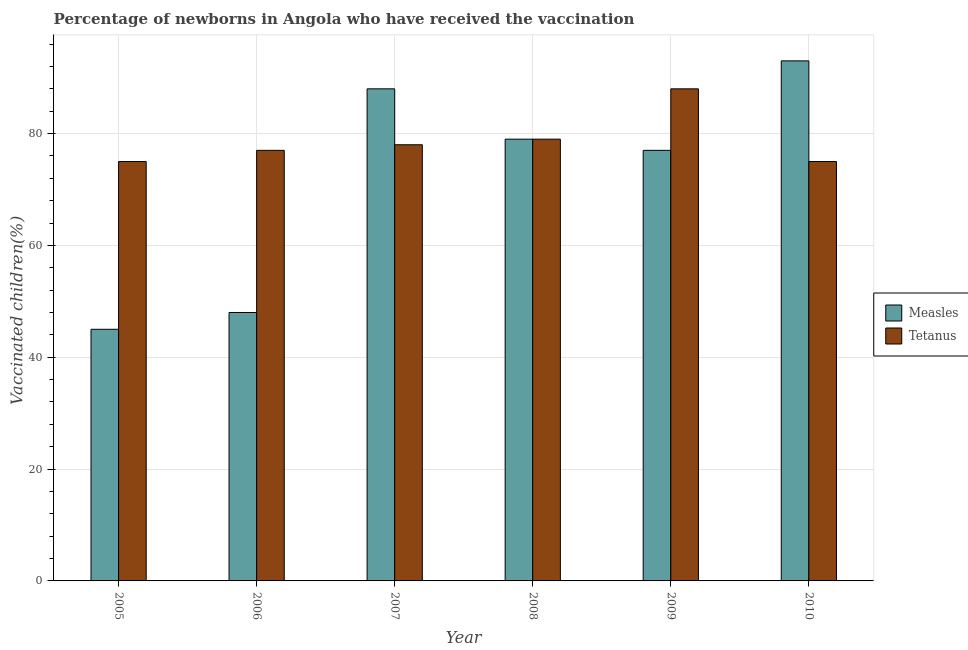How many groups of bars are there?
Your response must be concise. 6. Are the number of bars per tick equal to the number of legend labels?
Offer a very short reply. Yes. Are the number of bars on each tick of the X-axis equal?
Your answer should be very brief. Yes. How many bars are there on the 5th tick from the left?
Your answer should be compact. 2. How many bars are there on the 6th tick from the right?
Your answer should be compact. 2. In how many cases, is the number of bars for a given year not equal to the number of legend labels?
Your answer should be compact. 0. What is the percentage of newborns who received vaccination for measles in 2007?
Your response must be concise. 88. Across all years, what is the maximum percentage of newborns who received vaccination for measles?
Provide a succinct answer. 93. Across all years, what is the minimum percentage of newborns who received vaccination for tetanus?
Ensure brevity in your answer.  75. In which year was the percentage of newborns who received vaccination for measles maximum?
Keep it short and to the point. 2010. What is the total percentage of newborns who received vaccination for measles in the graph?
Ensure brevity in your answer.  430. What is the difference between the percentage of newborns who received vaccination for tetanus in 2005 and that in 2006?
Provide a succinct answer. -2. What is the difference between the percentage of newborns who received vaccination for measles in 2005 and the percentage of newborns who received vaccination for tetanus in 2006?
Ensure brevity in your answer.  -3. What is the average percentage of newborns who received vaccination for tetanus per year?
Offer a terse response. 78.67. What is the ratio of the percentage of newborns who received vaccination for tetanus in 2005 to that in 2008?
Ensure brevity in your answer.  0.95. Is the percentage of newborns who received vaccination for measles in 2005 less than that in 2006?
Keep it short and to the point. Yes. What is the difference between the highest and the second highest percentage of newborns who received vaccination for tetanus?
Your answer should be very brief. 9. What is the difference between the highest and the lowest percentage of newborns who received vaccination for measles?
Provide a short and direct response. 48. What does the 1st bar from the left in 2005 represents?
Offer a very short reply. Measles. What does the 1st bar from the right in 2006 represents?
Make the answer very short. Tetanus. How many bars are there?
Ensure brevity in your answer.  12. Are all the bars in the graph horizontal?
Provide a succinct answer. No. Where does the legend appear in the graph?
Your answer should be very brief. Center right. How many legend labels are there?
Your answer should be compact. 2. What is the title of the graph?
Your answer should be compact. Percentage of newborns in Angola who have received the vaccination. Does "Females" appear as one of the legend labels in the graph?
Offer a very short reply. No. What is the label or title of the X-axis?
Offer a terse response. Year. What is the label or title of the Y-axis?
Ensure brevity in your answer.  Vaccinated children(%)
. What is the Vaccinated children(%)
 in Measles in 2006?
Your answer should be very brief. 48. What is the Vaccinated children(%)
 in Tetanus in 2006?
Your answer should be compact. 77. What is the Vaccinated children(%)
 in Measles in 2007?
Offer a very short reply. 88. What is the Vaccinated children(%)
 in Measles in 2008?
Your answer should be compact. 79. What is the Vaccinated children(%)
 in Tetanus in 2008?
Your answer should be compact. 79. What is the Vaccinated children(%)
 in Measles in 2009?
Provide a succinct answer. 77. What is the Vaccinated children(%)
 of Measles in 2010?
Your response must be concise. 93. Across all years, what is the maximum Vaccinated children(%)
 in Measles?
Offer a terse response. 93. Across all years, what is the minimum Vaccinated children(%)
 of Tetanus?
Your answer should be very brief. 75. What is the total Vaccinated children(%)
 in Measles in the graph?
Offer a terse response. 430. What is the total Vaccinated children(%)
 of Tetanus in the graph?
Your response must be concise. 472. What is the difference between the Vaccinated children(%)
 in Measles in 2005 and that in 2006?
Give a very brief answer. -3. What is the difference between the Vaccinated children(%)
 of Tetanus in 2005 and that in 2006?
Provide a succinct answer. -2. What is the difference between the Vaccinated children(%)
 of Measles in 2005 and that in 2007?
Your answer should be very brief. -43. What is the difference between the Vaccinated children(%)
 in Measles in 2005 and that in 2008?
Provide a short and direct response. -34. What is the difference between the Vaccinated children(%)
 in Measles in 2005 and that in 2009?
Your answer should be very brief. -32. What is the difference between the Vaccinated children(%)
 of Tetanus in 2005 and that in 2009?
Your answer should be compact. -13. What is the difference between the Vaccinated children(%)
 of Measles in 2005 and that in 2010?
Keep it short and to the point. -48. What is the difference between the Vaccinated children(%)
 of Tetanus in 2005 and that in 2010?
Your answer should be very brief. 0. What is the difference between the Vaccinated children(%)
 in Measles in 2006 and that in 2008?
Your response must be concise. -31. What is the difference between the Vaccinated children(%)
 in Measles in 2006 and that in 2009?
Your answer should be compact. -29. What is the difference between the Vaccinated children(%)
 of Tetanus in 2006 and that in 2009?
Make the answer very short. -11. What is the difference between the Vaccinated children(%)
 in Measles in 2006 and that in 2010?
Provide a short and direct response. -45. What is the difference between the Vaccinated children(%)
 of Measles in 2007 and that in 2008?
Offer a terse response. 9. What is the difference between the Vaccinated children(%)
 of Tetanus in 2007 and that in 2009?
Keep it short and to the point. -10. What is the difference between the Vaccinated children(%)
 in Measles in 2007 and that in 2010?
Offer a terse response. -5. What is the difference between the Vaccinated children(%)
 in Tetanus in 2007 and that in 2010?
Give a very brief answer. 3. What is the difference between the Vaccinated children(%)
 of Measles in 2008 and that in 2009?
Make the answer very short. 2. What is the difference between the Vaccinated children(%)
 of Tetanus in 2008 and that in 2010?
Provide a succinct answer. 4. What is the difference between the Vaccinated children(%)
 in Measles in 2009 and that in 2010?
Provide a succinct answer. -16. What is the difference between the Vaccinated children(%)
 in Measles in 2005 and the Vaccinated children(%)
 in Tetanus in 2006?
Make the answer very short. -32. What is the difference between the Vaccinated children(%)
 of Measles in 2005 and the Vaccinated children(%)
 of Tetanus in 2007?
Provide a succinct answer. -33. What is the difference between the Vaccinated children(%)
 in Measles in 2005 and the Vaccinated children(%)
 in Tetanus in 2008?
Keep it short and to the point. -34. What is the difference between the Vaccinated children(%)
 in Measles in 2005 and the Vaccinated children(%)
 in Tetanus in 2009?
Your answer should be compact. -43. What is the difference between the Vaccinated children(%)
 in Measles in 2006 and the Vaccinated children(%)
 in Tetanus in 2007?
Ensure brevity in your answer.  -30. What is the difference between the Vaccinated children(%)
 of Measles in 2006 and the Vaccinated children(%)
 of Tetanus in 2008?
Offer a terse response. -31. What is the difference between the Vaccinated children(%)
 of Measles in 2006 and the Vaccinated children(%)
 of Tetanus in 2010?
Offer a very short reply. -27. What is the difference between the Vaccinated children(%)
 in Measles in 2007 and the Vaccinated children(%)
 in Tetanus in 2009?
Your response must be concise. 0. What is the difference between the Vaccinated children(%)
 of Measles in 2007 and the Vaccinated children(%)
 of Tetanus in 2010?
Offer a terse response. 13. What is the difference between the Vaccinated children(%)
 of Measles in 2008 and the Vaccinated children(%)
 of Tetanus in 2010?
Provide a succinct answer. 4. What is the difference between the Vaccinated children(%)
 of Measles in 2009 and the Vaccinated children(%)
 of Tetanus in 2010?
Provide a succinct answer. 2. What is the average Vaccinated children(%)
 in Measles per year?
Give a very brief answer. 71.67. What is the average Vaccinated children(%)
 of Tetanus per year?
Provide a succinct answer. 78.67. In the year 2006, what is the difference between the Vaccinated children(%)
 in Measles and Vaccinated children(%)
 in Tetanus?
Provide a short and direct response. -29. What is the ratio of the Vaccinated children(%)
 of Measles in 2005 to that in 2007?
Offer a terse response. 0.51. What is the ratio of the Vaccinated children(%)
 in Tetanus in 2005 to that in 2007?
Keep it short and to the point. 0.96. What is the ratio of the Vaccinated children(%)
 in Measles in 2005 to that in 2008?
Make the answer very short. 0.57. What is the ratio of the Vaccinated children(%)
 in Tetanus in 2005 to that in 2008?
Give a very brief answer. 0.95. What is the ratio of the Vaccinated children(%)
 of Measles in 2005 to that in 2009?
Your response must be concise. 0.58. What is the ratio of the Vaccinated children(%)
 of Tetanus in 2005 to that in 2009?
Ensure brevity in your answer.  0.85. What is the ratio of the Vaccinated children(%)
 in Measles in 2005 to that in 2010?
Give a very brief answer. 0.48. What is the ratio of the Vaccinated children(%)
 of Measles in 2006 to that in 2007?
Keep it short and to the point. 0.55. What is the ratio of the Vaccinated children(%)
 in Tetanus in 2006 to that in 2007?
Offer a very short reply. 0.99. What is the ratio of the Vaccinated children(%)
 of Measles in 2006 to that in 2008?
Keep it short and to the point. 0.61. What is the ratio of the Vaccinated children(%)
 of Tetanus in 2006 to that in 2008?
Give a very brief answer. 0.97. What is the ratio of the Vaccinated children(%)
 in Measles in 2006 to that in 2009?
Give a very brief answer. 0.62. What is the ratio of the Vaccinated children(%)
 in Measles in 2006 to that in 2010?
Make the answer very short. 0.52. What is the ratio of the Vaccinated children(%)
 of Tetanus in 2006 to that in 2010?
Offer a terse response. 1.03. What is the ratio of the Vaccinated children(%)
 in Measles in 2007 to that in 2008?
Ensure brevity in your answer.  1.11. What is the ratio of the Vaccinated children(%)
 in Tetanus in 2007 to that in 2008?
Your response must be concise. 0.99. What is the ratio of the Vaccinated children(%)
 in Tetanus in 2007 to that in 2009?
Ensure brevity in your answer.  0.89. What is the ratio of the Vaccinated children(%)
 of Measles in 2007 to that in 2010?
Provide a succinct answer. 0.95. What is the ratio of the Vaccinated children(%)
 in Tetanus in 2007 to that in 2010?
Your response must be concise. 1.04. What is the ratio of the Vaccinated children(%)
 in Tetanus in 2008 to that in 2009?
Keep it short and to the point. 0.9. What is the ratio of the Vaccinated children(%)
 in Measles in 2008 to that in 2010?
Offer a terse response. 0.85. What is the ratio of the Vaccinated children(%)
 in Tetanus in 2008 to that in 2010?
Your answer should be very brief. 1.05. What is the ratio of the Vaccinated children(%)
 in Measles in 2009 to that in 2010?
Your answer should be very brief. 0.83. What is the ratio of the Vaccinated children(%)
 in Tetanus in 2009 to that in 2010?
Ensure brevity in your answer.  1.17. What is the difference between the highest and the second highest Vaccinated children(%)
 of Tetanus?
Give a very brief answer. 9. What is the difference between the highest and the lowest Vaccinated children(%)
 in Measles?
Your response must be concise. 48. What is the difference between the highest and the lowest Vaccinated children(%)
 in Tetanus?
Provide a succinct answer. 13. 